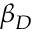Convert formula to latex. <formula><loc_0><loc_0><loc_500><loc_500>\beta _ { D }</formula> 